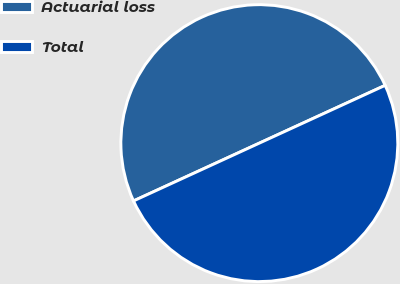Convert chart to OTSL. <chart><loc_0><loc_0><loc_500><loc_500><pie_chart><fcel>Actuarial loss<fcel>Total<nl><fcel>50.0%<fcel>50.0%<nl></chart> 